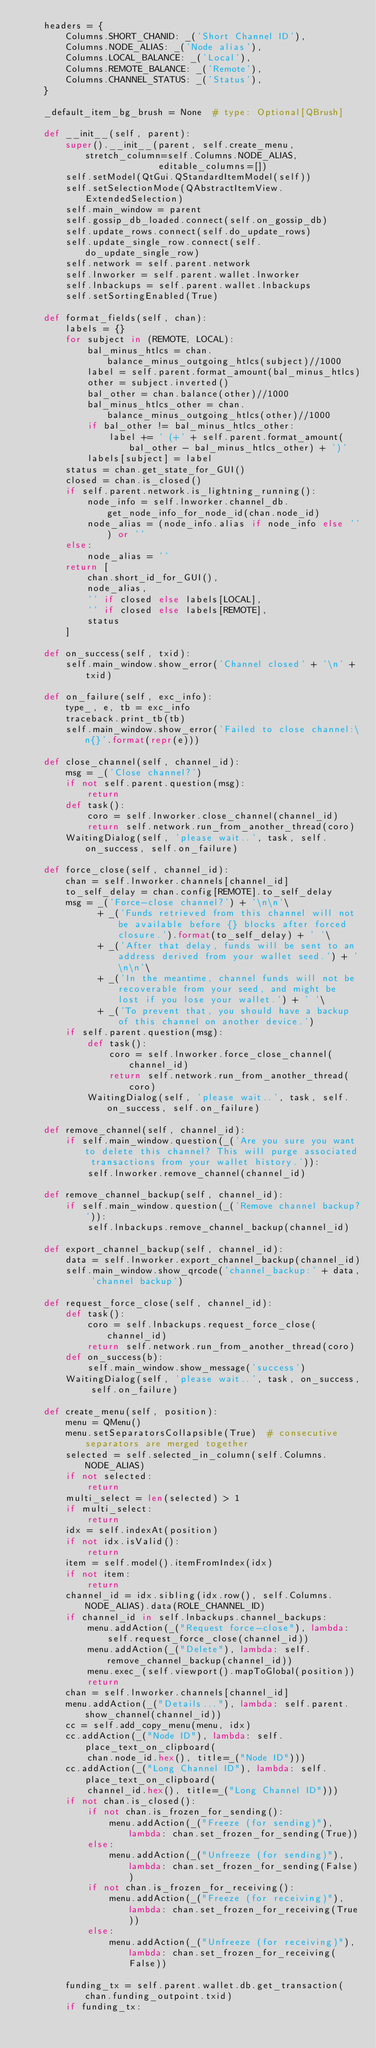<code> <loc_0><loc_0><loc_500><loc_500><_Python_>    headers = {
        Columns.SHORT_CHANID: _('Short Channel ID'),
        Columns.NODE_ALIAS: _('Node alias'),
        Columns.LOCAL_BALANCE: _('Local'),
        Columns.REMOTE_BALANCE: _('Remote'),
        Columns.CHANNEL_STATUS: _('Status'),
    }

    _default_item_bg_brush = None  # type: Optional[QBrush]

    def __init__(self, parent):
        super().__init__(parent, self.create_menu, stretch_column=self.Columns.NODE_ALIAS,
                         editable_columns=[])
        self.setModel(QtGui.QStandardItemModel(self))
        self.setSelectionMode(QAbstractItemView.ExtendedSelection)
        self.main_window = parent
        self.gossip_db_loaded.connect(self.on_gossip_db)
        self.update_rows.connect(self.do_update_rows)
        self.update_single_row.connect(self.do_update_single_row)
        self.network = self.parent.network
        self.lnworker = self.parent.wallet.lnworker
        self.lnbackups = self.parent.wallet.lnbackups
        self.setSortingEnabled(True)

    def format_fields(self, chan):
        labels = {}
        for subject in (REMOTE, LOCAL):
            bal_minus_htlcs = chan.balance_minus_outgoing_htlcs(subject)//1000
            label = self.parent.format_amount(bal_minus_htlcs)
            other = subject.inverted()
            bal_other = chan.balance(other)//1000
            bal_minus_htlcs_other = chan.balance_minus_outgoing_htlcs(other)//1000
            if bal_other != bal_minus_htlcs_other:
                label += ' (+' + self.parent.format_amount(bal_other - bal_minus_htlcs_other) + ')'
            labels[subject] = label
        status = chan.get_state_for_GUI()
        closed = chan.is_closed()
        if self.parent.network.is_lightning_running():
            node_info = self.lnworker.channel_db.get_node_info_for_node_id(chan.node_id)
            node_alias = (node_info.alias if node_info else '') or ''
        else:
            node_alias = ''
        return [
            chan.short_id_for_GUI(),
            node_alias,
            '' if closed else labels[LOCAL],
            '' if closed else labels[REMOTE],
            status
        ]

    def on_success(self, txid):
        self.main_window.show_error('Channel closed' + '\n' + txid)

    def on_failure(self, exc_info):
        type_, e, tb = exc_info
        traceback.print_tb(tb)
        self.main_window.show_error('Failed to close channel:\n{}'.format(repr(e)))

    def close_channel(self, channel_id):
        msg = _('Close channel?')
        if not self.parent.question(msg):
            return
        def task():
            coro = self.lnworker.close_channel(channel_id)
            return self.network.run_from_another_thread(coro)
        WaitingDialog(self, 'please wait..', task, self.on_success, self.on_failure)

    def force_close(self, channel_id):
        chan = self.lnworker.channels[channel_id]
        to_self_delay = chan.config[REMOTE].to_self_delay
        msg = _('Force-close channel?') + '\n\n'\
              + _('Funds retrieved from this channel will not be available before {} blocks after forced closure.').format(to_self_delay) + ' '\
              + _('After that delay, funds will be sent to an address derived from your wallet seed.') + '\n\n'\
              + _('In the meantime, channel funds will not be recoverable from your seed, and might be lost if you lose your wallet.') + ' '\
              + _('To prevent that, you should have a backup of this channel on another device.')
        if self.parent.question(msg):
            def task():
                coro = self.lnworker.force_close_channel(channel_id)
                return self.network.run_from_another_thread(coro)
            WaitingDialog(self, 'please wait..', task, self.on_success, self.on_failure)

    def remove_channel(self, channel_id):
        if self.main_window.question(_('Are you sure you want to delete this channel? This will purge associated transactions from your wallet history.')):
            self.lnworker.remove_channel(channel_id)

    def remove_channel_backup(self, channel_id):
        if self.main_window.question(_('Remove channel backup?')):
            self.lnbackups.remove_channel_backup(channel_id)

    def export_channel_backup(self, channel_id):
        data = self.lnworker.export_channel_backup(channel_id)
        self.main_window.show_qrcode('channel_backup:' + data, 'channel backup')

    def request_force_close(self, channel_id):
        def task():
            coro = self.lnbackups.request_force_close(channel_id)
            return self.network.run_from_another_thread(coro)
        def on_success(b):
            self.main_window.show_message('success')
        WaitingDialog(self, 'please wait..', task, on_success, self.on_failure)

    def create_menu(self, position):
        menu = QMenu()
        menu.setSeparatorsCollapsible(True)  # consecutive separators are merged together
        selected = self.selected_in_column(self.Columns.NODE_ALIAS)
        if not selected:
            return
        multi_select = len(selected) > 1
        if multi_select:
            return
        idx = self.indexAt(position)
        if not idx.isValid():
            return
        item = self.model().itemFromIndex(idx)
        if not item:
            return
        channel_id = idx.sibling(idx.row(), self.Columns.NODE_ALIAS).data(ROLE_CHANNEL_ID)
        if channel_id in self.lnbackups.channel_backups:
            menu.addAction(_("Request force-close"), lambda: self.request_force_close(channel_id))
            menu.addAction(_("Delete"), lambda: self.remove_channel_backup(channel_id))
            menu.exec_(self.viewport().mapToGlobal(position))
            return
        chan = self.lnworker.channels[channel_id]
        menu.addAction(_("Details..."), lambda: self.parent.show_channel(channel_id))
        cc = self.add_copy_menu(menu, idx)
        cc.addAction(_("Node ID"), lambda: self.place_text_on_clipboard(
            chan.node_id.hex(), title=_("Node ID")))
        cc.addAction(_("Long Channel ID"), lambda: self.place_text_on_clipboard(
            channel_id.hex(), title=_("Long Channel ID")))
        if not chan.is_closed():
            if not chan.is_frozen_for_sending():
                menu.addAction(_("Freeze (for sending)"), lambda: chan.set_frozen_for_sending(True))
            else:
                menu.addAction(_("Unfreeze (for sending)"), lambda: chan.set_frozen_for_sending(False))
            if not chan.is_frozen_for_receiving():
                menu.addAction(_("Freeze (for receiving)"), lambda: chan.set_frozen_for_receiving(True))
            else:
                menu.addAction(_("Unfreeze (for receiving)"), lambda: chan.set_frozen_for_receiving(False))

        funding_tx = self.parent.wallet.db.get_transaction(chan.funding_outpoint.txid)
        if funding_tx:</code> 